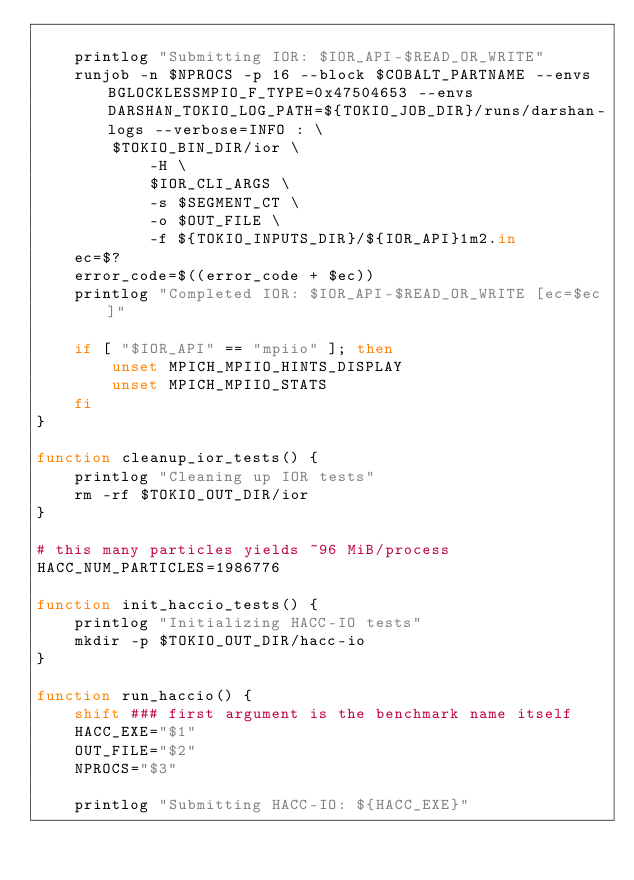<code> <loc_0><loc_0><loc_500><loc_500><_Bash_>
    printlog "Submitting IOR: $IOR_API-$READ_OR_WRITE"
    runjob -n $NPROCS -p 16 --block $COBALT_PARTNAME --envs BGLOCKLESSMPIO_F_TYPE=0x47504653 --envs DARSHAN_TOKIO_LOG_PATH=${TOKIO_JOB_DIR}/runs/darshan-logs --verbose=INFO : \
        $TOKIO_BIN_DIR/ior \
            -H \
            $IOR_CLI_ARGS \
            -s $SEGMENT_CT \
            -o $OUT_FILE \
            -f ${TOKIO_INPUTS_DIR}/${IOR_API}1m2.in
    ec=$?
    error_code=$((error_code + $ec))
    printlog "Completed IOR: $IOR_API-$READ_OR_WRITE [ec=$ec]"

    if [ "$IOR_API" == "mpiio" ]; then
        unset MPICH_MPIIO_HINTS_DISPLAY
        unset MPICH_MPIIO_STATS
    fi
}

function cleanup_ior_tests() {
    printlog "Cleaning up IOR tests"
    rm -rf $TOKIO_OUT_DIR/ior
}

# this many particles yields ~96 MiB/process
HACC_NUM_PARTICLES=1986776

function init_haccio_tests() {
    printlog "Initializing HACC-IO tests"
    mkdir -p $TOKIO_OUT_DIR/hacc-io
}

function run_haccio() {
    shift ### first argument is the benchmark name itself
    HACC_EXE="$1"
    OUT_FILE="$2"
    NPROCS="$3"

    printlog "Submitting HACC-IO: ${HACC_EXE}"</code> 